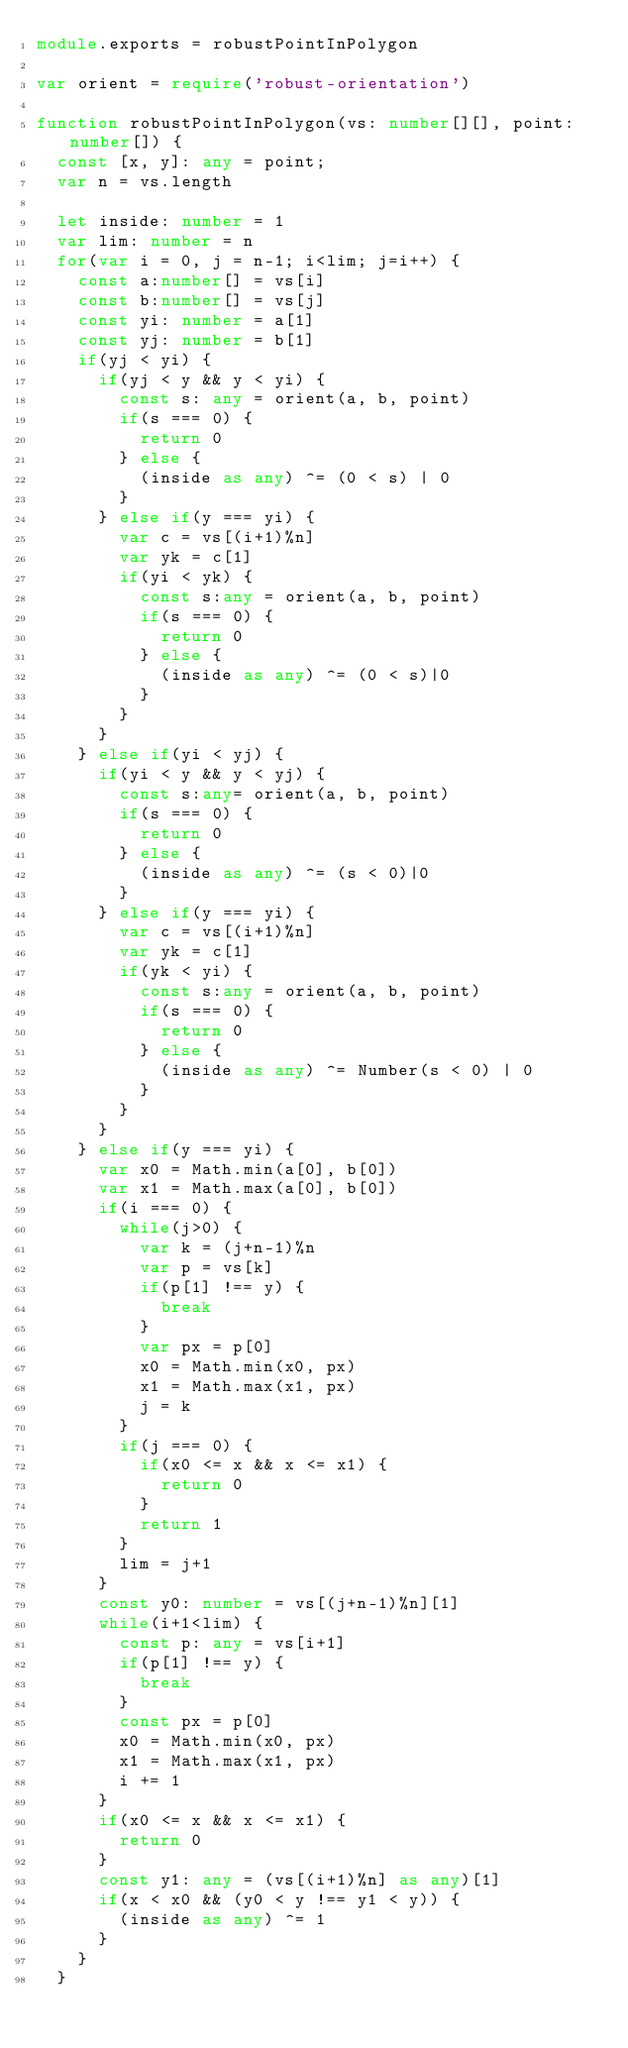<code> <loc_0><loc_0><loc_500><loc_500><_TypeScript_>module.exports = robustPointInPolygon

var orient = require('robust-orientation')

function robustPointInPolygon(vs: number[][], point: number[]) {
  const [x, y]: any = point;
  var n = vs.length

  let inside: number = 1
  var lim: number = n
  for(var i = 0, j = n-1; i<lim; j=i++) {
    const a:number[] = vs[i]
    const b:number[] = vs[j]
    const yi: number = a[1]
    const yj: number = b[1]
    if(yj < yi) {
      if(yj < y && y < yi) {
        const s: any = orient(a, b, point)
        if(s === 0) {
          return 0
        } else {
          (inside as any) ^= (0 < s) | 0
        }
      } else if(y === yi) {
        var c = vs[(i+1)%n]
        var yk = c[1]
        if(yi < yk) {
          const s:any = orient(a, b, point)
          if(s === 0) {
            return 0
          } else {
            (inside as any) ^= (0 < s)|0
          }
        }
      }
    } else if(yi < yj) {
      if(yi < y && y < yj) {
        const s:any= orient(a, b, point)
        if(s === 0) {
          return 0
        } else {
          (inside as any) ^= (s < 0)|0
        }
      } else if(y === yi) {
        var c = vs[(i+1)%n]
        var yk = c[1]
        if(yk < yi) {
          const s:any = orient(a, b, point)
          if(s === 0) {
            return 0
          } else {
            (inside as any) ^= Number(s < 0) | 0
          }
        }
      }
    } else if(y === yi) {
      var x0 = Math.min(a[0], b[0])
      var x1 = Math.max(a[0], b[0])
      if(i === 0) {
        while(j>0) {
          var k = (j+n-1)%n
          var p = vs[k]
          if(p[1] !== y) {
            break
          }
          var px = p[0]
          x0 = Math.min(x0, px)
          x1 = Math.max(x1, px)
          j = k
        }
        if(j === 0) {
          if(x0 <= x && x <= x1) {
            return 0
          }
          return 1
        }
        lim = j+1
      }
      const y0: number = vs[(j+n-1)%n][1]
      while(i+1<lim) {
        const p: any = vs[i+1]
        if(p[1] !== y) {
          break
        }
        const px = p[0]
        x0 = Math.min(x0, px)
        x1 = Math.max(x1, px)
        i += 1
      }
      if(x0 <= x && x <= x1) {
        return 0
      }
      const y1: any = (vs[(i+1)%n] as any)[1]
      if(x < x0 && (y0 < y !== y1 < y)) {
        (inside as any) ^= 1
      }
    }
  }</code> 